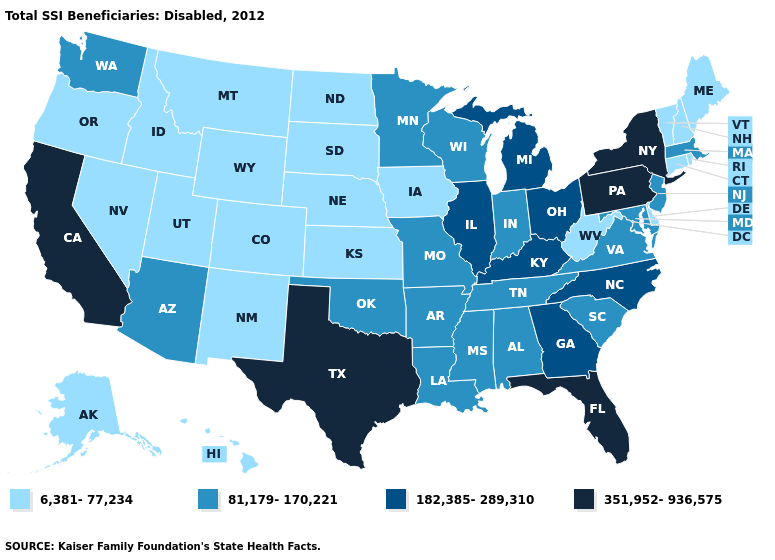Does Texas have the highest value in the South?
Keep it brief. Yes. Name the states that have a value in the range 182,385-289,310?
Answer briefly. Georgia, Illinois, Kentucky, Michigan, North Carolina, Ohio. Does West Virginia have the lowest value in the USA?
Quick response, please. Yes. What is the highest value in states that border Mississippi?
Quick response, please. 81,179-170,221. Does Alabama have a lower value than Illinois?
Write a very short answer. Yes. Name the states that have a value in the range 81,179-170,221?
Write a very short answer. Alabama, Arizona, Arkansas, Indiana, Louisiana, Maryland, Massachusetts, Minnesota, Mississippi, Missouri, New Jersey, Oklahoma, South Carolina, Tennessee, Virginia, Washington, Wisconsin. What is the value of New Hampshire?
Concise answer only. 6,381-77,234. Name the states that have a value in the range 351,952-936,575?
Answer briefly. California, Florida, New York, Pennsylvania, Texas. What is the value of Nevada?
Concise answer only. 6,381-77,234. What is the lowest value in the USA?
Give a very brief answer. 6,381-77,234. Name the states that have a value in the range 182,385-289,310?
Be succinct. Georgia, Illinois, Kentucky, Michigan, North Carolina, Ohio. Does Arkansas have a higher value than North Carolina?
Keep it brief. No. Does Wisconsin have the same value as New York?
Be succinct. No. Does Iowa have the lowest value in the USA?
Keep it brief. Yes. What is the lowest value in the USA?
Give a very brief answer. 6,381-77,234. 